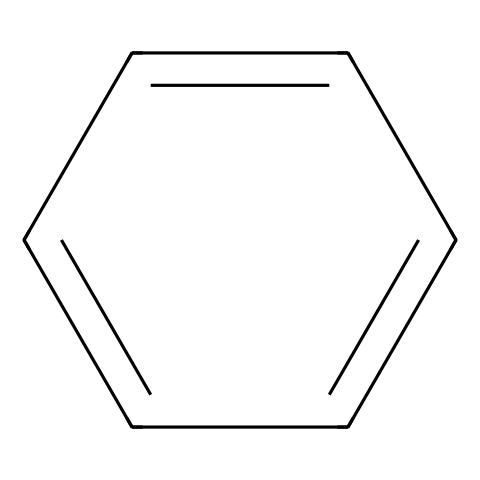What is the molecular formula of benzene? Benzene has six carbon atoms and six hydrogen atoms, which can be derived from its structure where each carbon forms a bond with one hydrogen and is arranged in a closed ring.
Answer: C6H6 How many hydrogen atoms are in benzene? The SMILES representation indicates six hydrogen atoms are connected to the six carbon atoms in the ring, as each carbon is bonded to one hydrogen.
Answer: 6 What type of hydrocarbon is benzene? The structure of benzene includes alternating double bonds between carbon atoms, characteristic of aromatic hydrocarbons, which have unique stability and resonance.
Answer: aromatic How many degrees of unsaturation does benzene have? Benzene has 4 degrees of unsaturation, as each aromatic ring can be represented as a structure with alternating double bonds, indicating multiple bonds or rings present.
Answer: 4 What is the hybridization of the carbon atoms in benzene? In benzene, each carbon atom is sp2 hybridized, as they form three sigma bonds with adjacent atoms and one delocalized pi bond throughout the ring.
Answer: sp2 Why is benzene considered a stable compound? Benzene’s stability arises from resonance; the delocalization of electrons across the molecule leads to lower energy and a more stable arrangement, which prevents reactivity like alkenes.
Answer: resonance What is the bond angle between carbon atoms in benzene? The bond angles in benzene are approximately 120 degrees due to the sp2 hybridization of the carbon atoms, creating a planar structure.
Answer: 120 degrees 